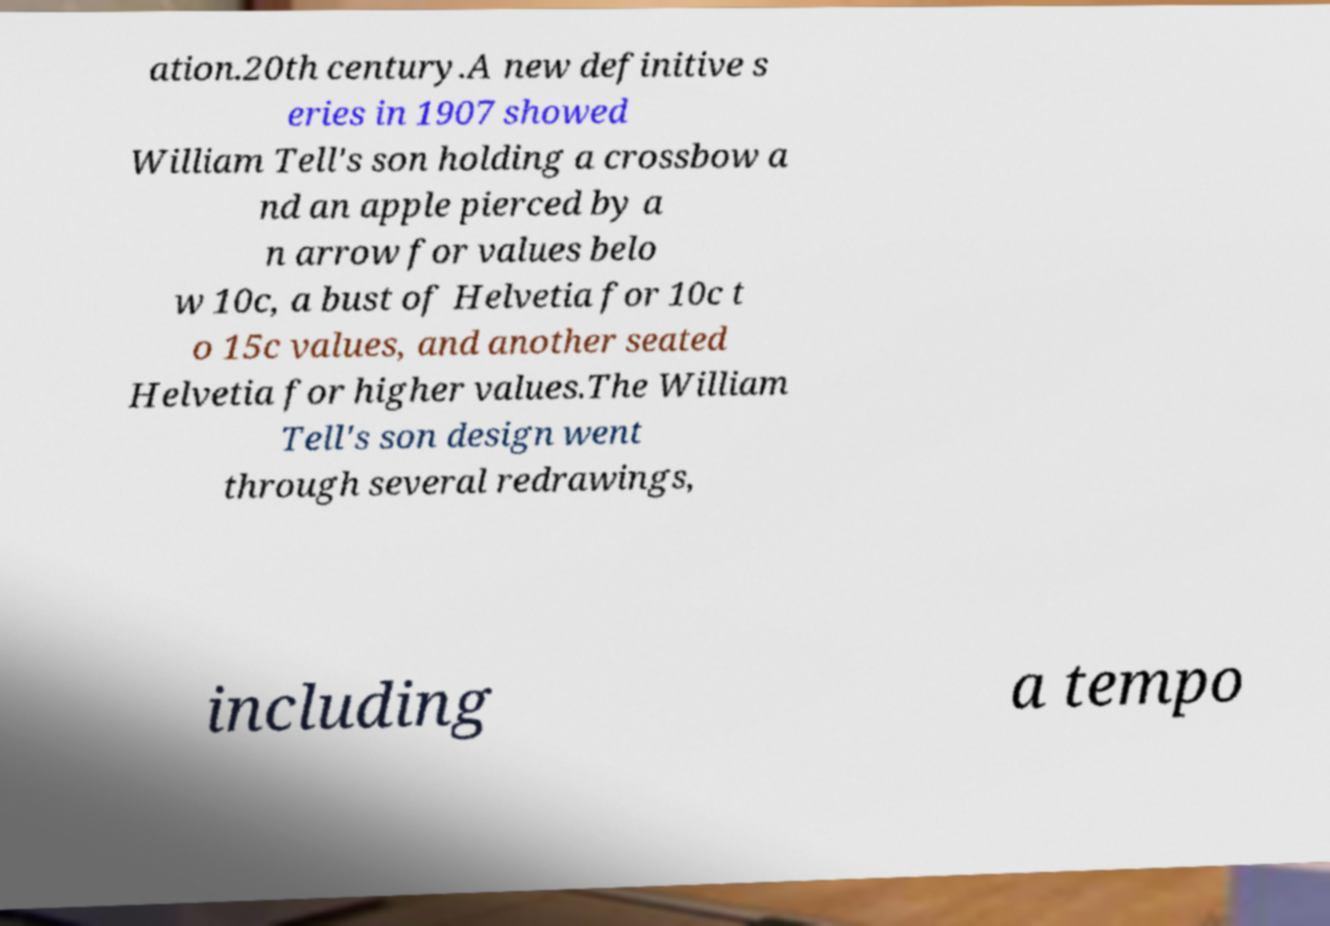Can you read and provide the text displayed in the image?This photo seems to have some interesting text. Can you extract and type it out for me? ation.20th century.A new definitive s eries in 1907 showed William Tell's son holding a crossbow a nd an apple pierced by a n arrow for values belo w 10c, a bust of Helvetia for 10c t o 15c values, and another seated Helvetia for higher values.The William Tell's son design went through several redrawings, including a tempo 